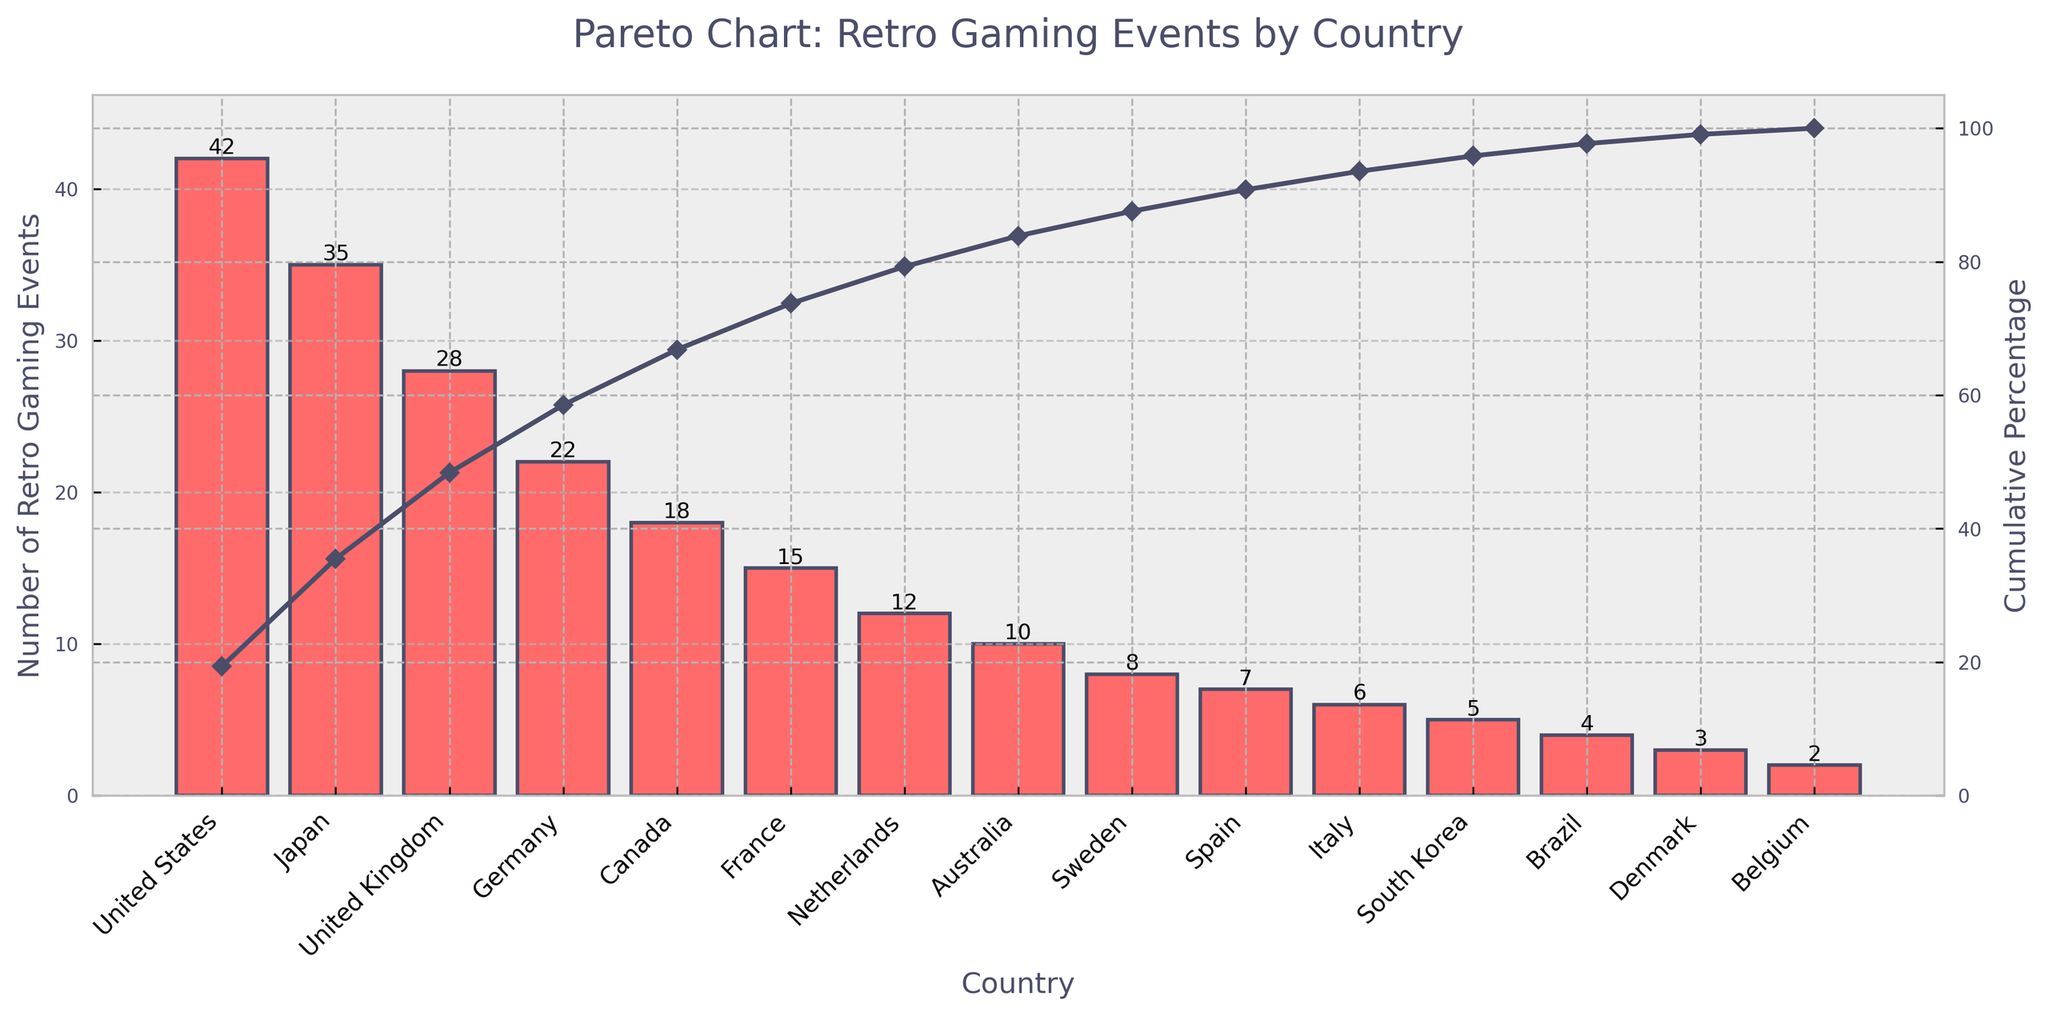what is the title of the chart? The title of the chart is typically located at the top of the figure. In this case, it reads "Pareto Chart: Retro Gaming Events by Country."
Answer: Pareto Chart: Retro Gaming Events by Country How many retro gaming events are held in Germany? To find the number of retro gaming events in Germany, look for the bar labeled "Germany" on the x-axis and read its height. The adjoining label on top of the bar indicates the exact number.
Answer: 22 Which country has the highest number of retro gaming events? To identify the country with the highest number of retro gaming events, locate the tallest bar in the chart. The country's name corresponding to this bar is the answer.
Answer: United States What is the cumulative percentage after adding the retro gaming events of the United Kingdom? To find the cumulative percentage for the United Kingdom, locate the point on the cumulative percentage line graph that corresponds to the United Kingdom on the x-axis, and read the value on the secondary y-axis (right).
Answer: ~64% Which countries have fewer than 10 retro gaming events? To find countries with fewer than 10 retro gaming events, look for bars whose heights are less than 10 and identify the countries they represent.
Answer: Sweden, Spain, Italy, South Korea, Brazil, Denmark, Belgium What is the sum of retro gaming events in Japan, Canada, and France? Add the number of retro gaming events for Japan (35), Canada (18), and France (15). The sum is 35 + 18 + 15.
Answer: 68 What is the cumulative percentage after adding Sweden's retro gaming events? Identify the point on the cumulative percentage line graph for Sweden, then read the corresponding value on the secondary y-axis.
Answer: ~90% Between Australia and the Netherlands, which country has more retro gaming events? Compare the heights of the bars for Australia and the Netherlands. The taller bar represents the country with more events.
Answer: Netherlands Do the top three countries account for more than 50% of the total retro gaming events? Sum the number of retro gaming events for the top three countries (United States, Japan, United Kingdom) and then divide by the total events. Multiply by 100 to get the percentage and check if it exceeds 50%.
Answer: Yes What percentage of the total events do the top five countries represent? Sum the number of events for the top five countries and divide by the total events, then multiply by 100 to get the cumulative percentage. This includes the United States, Japan, United Kingdom, Germany, and Canada.
Answer: ~69% 